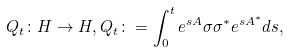Convert formula to latex. <formula><loc_0><loc_0><loc_500><loc_500>Q _ { t } \colon H \to H , Q _ { t } \colon = \int _ { 0 } ^ { t } e ^ { s A } \sigma \sigma ^ { \ast } e ^ { s A ^ { \ast } } d s ,</formula> 